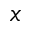Convert formula to latex. <formula><loc_0><loc_0><loc_500><loc_500>x</formula> 